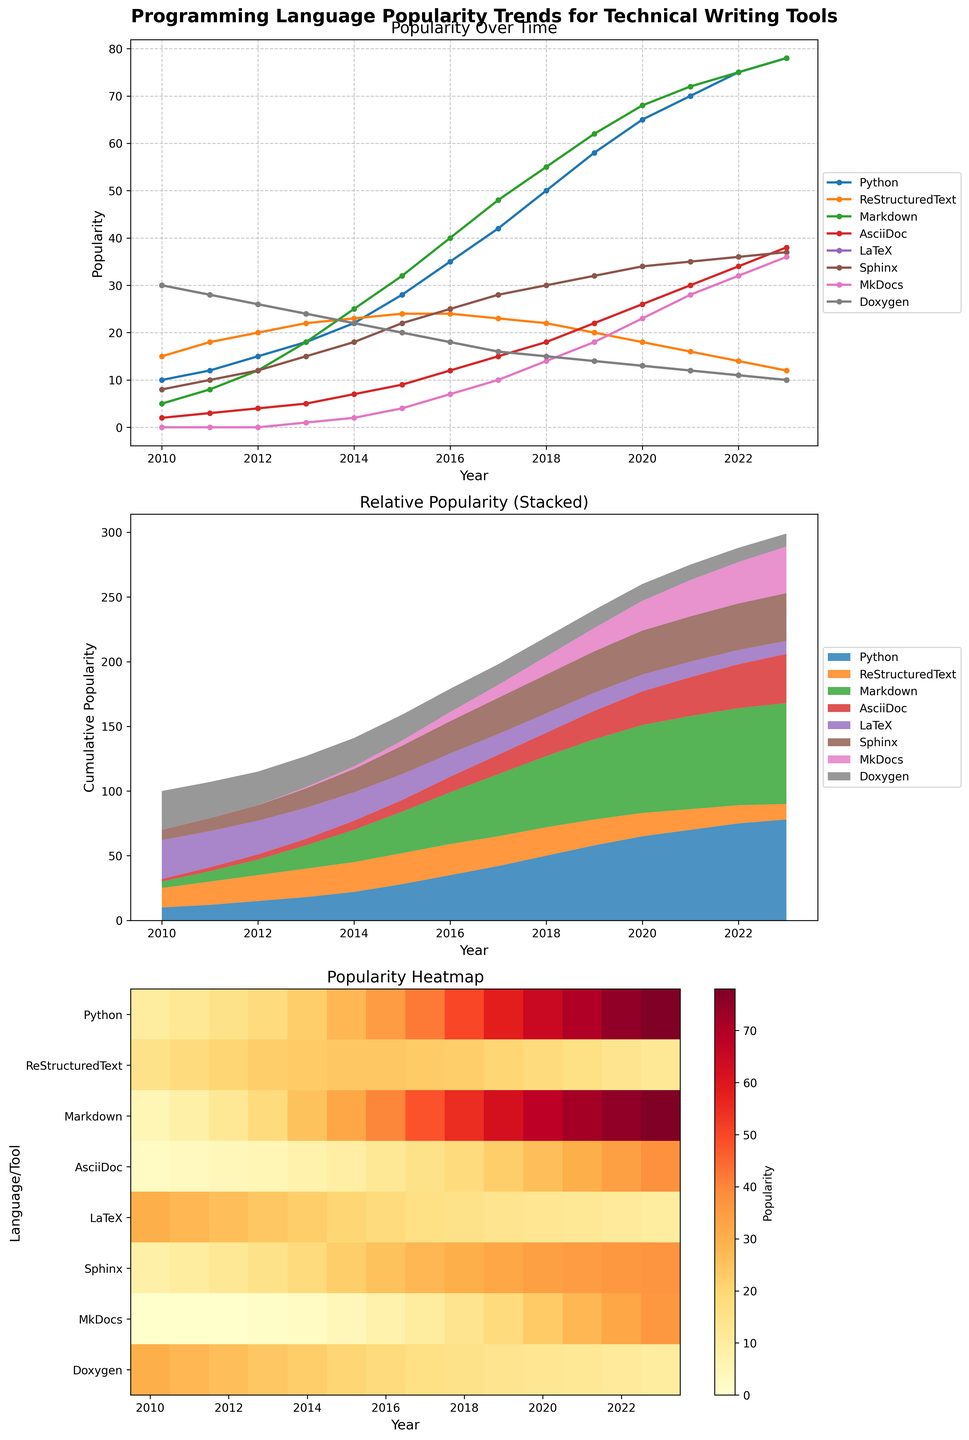When did Markdown first surpass the popularity of LaTeX? According to the line plot, Markdown surpassed LaTeX for the first time between 2015 and 2016. By tracking the lines of Markdown and LaTeX, you can see that Markdown's line crosses above LaTeX's line during this period.
Answer: Between 2015 and 2016 Which tool showed the most consistent decline in popularity from 2010 to 2023? Observing the line plot, ReStructuredText shows a consistent decline in popularity. Its trend line continually slopes downward across the years.
Answer: ReStructuredText In 2018, what was the difference in popularity between Python and Doxygen? According to the line plot, in 2018, Python had a popularity value of 50, and Doxygen had a value of 15. The difference is calculated as 50 - 15.
Answer: 35 How does the relative popularity of AsciiDoc compare to Python in the year 2023? In the heatmap, you can see the color intensity for each year across different tools. For the year 2023, AsciiDoc is represented by a lighter color compared to the much darker color of Python, indicating much lower popularity.
Answer: AsciiDoc is much less popular than Python Which programming tool showed the highest cumulative growth in the stacked area plot from 2010 to 2023? Observing the stacked area plot, Markdown's section grows the most from the bottom to the top compared to other tools. Its area increases significantly over time.
Answer: Markdown By how much did LaTeX's popularity decrease from 2010 to 2023? From the line plot, LaTeX's popularity was 30 in 2010 and dropped to 10 in 2023. The decrease is calculated as 30 - 10.
Answer: 20 In which year did Sphinx's popularity start leveling off? The line plot shows that Sphinx's popularity starts to level off around 2021, where the increase starts to become less steep.
Answer: Around 2021 What's the average popularity of MkDocs from 2016 to 2023? Extracting the values from the line plot for MkDocs from 2016 to 2023: 7, 10, 14, 18, 23, 28, 32, and 36, summing them up to get 168 and dividing by the number of years (8). The average is 168/8 = 21.
Answer: 21 Which year saw the biggest drop in Sphinx's popularity? Checking the Sphinx line in the line plot, the biggest drop occurs between 2017 and 2018, where it goes from 28 to 30.
Answer: Between 2017 and 2018 Overall, how did the popularity trend of Python compare to the other tools from 2010 to 2023? From the line plot, Python shows a sharp and consistent upward trend almost every year, distinguishing its growth rate from the more stable or declining trends of the other tools.
Answer: Sharply upward and consistent expansion 